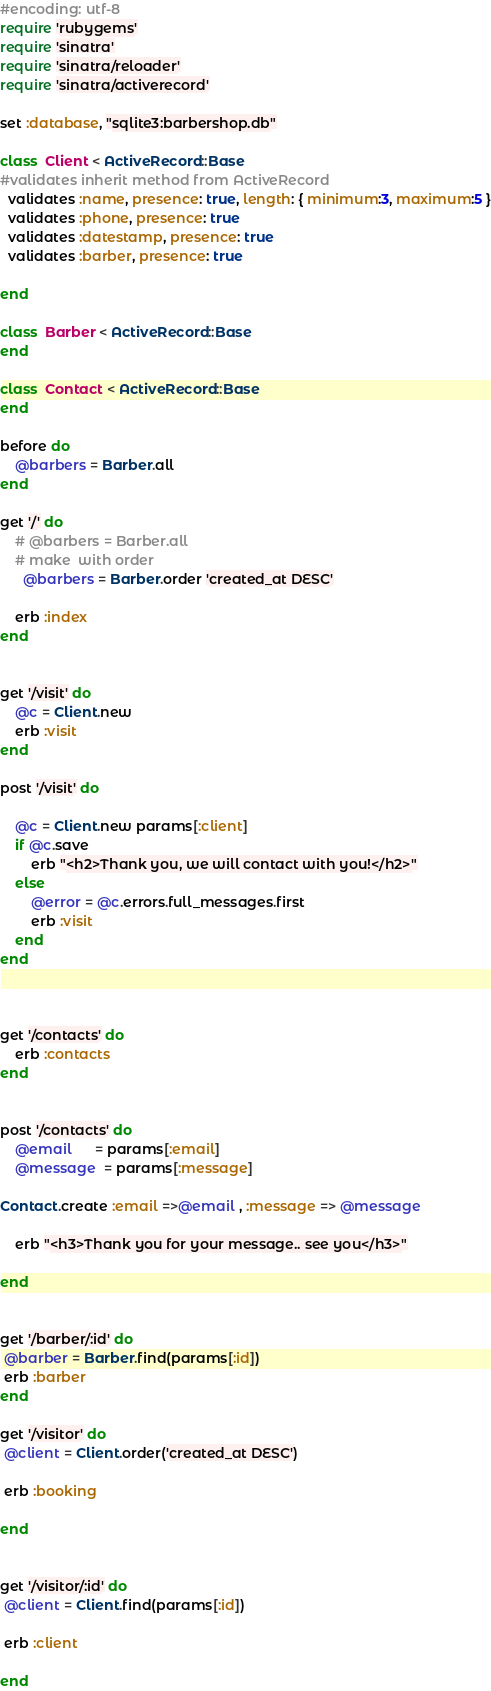Convert code to text. <code><loc_0><loc_0><loc_500><loc_500><_Ruby_>#encoding: utf-8
require 'rubygems'
require 'sinatra'
require 'sinatra/reloader'
require 'sinatra/activerecord'

set :database, "sqlite3:barbershop.db"

class  Client < ActiveRecord::Base
#validates inherit method from ActiveRecord
  validates :name, presence: true, length: { minimum:3, maximum:5 }
  validates :phone, presence: true
  validates :datestamp, presence: true
  validates :barber, presence: true

end

class  Barber < ActiveRecord::Base
end

class  Contact < ActiveRecord::Base
end

before do
	@barbers = Barber.all
end

get '/' do
	# @barbers = Barber.all
	# make  with order
	  @barbers = Barber.order 'created_at DESC'

	erb :index
end


get '/visit' do
	@c = Client.new
	erb :visit
end

post '/visit' do

	@c = Client.new params[:client]	
	if @c.save 
 		erb "<h2>Thank you, we will contact with you!</h2>"
 	else
 		@error = @c.errors.full_messages.first
 		erb :visit
 	end
end



get '/contacts' do
	erb :contacts
end


post '/contacts' do
	@email	  = params[:email]
	@message  = params[:message]

Contact.create :email =>@email , :message => @message

 	erb "<h3>Thank you for your message.. see you</h3>"

end


get '/barber/:id' do
 @barber = Barber.find(params[:id])
 erb :barber
end

get '/visitor' do
 @client = Client.order('created_at DESC')

 erb :booking

end


get '/visitor/:id' do
 @client = Client.find(params[:id])

 erb :client

end



</code> 